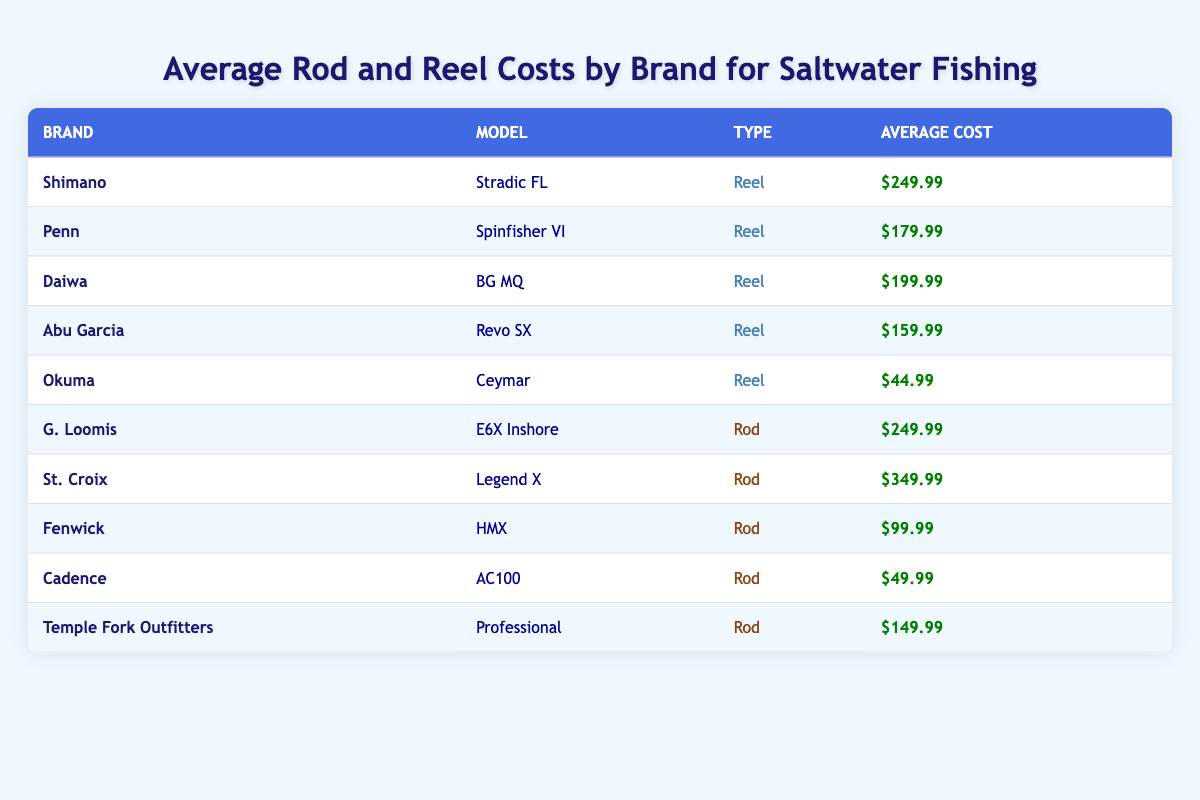What is the average cost of a rod from the table? To find the average cost of rods, we need to sum the average costs of the rods listed: \( 249.99 + 349.99 + 99.99 + 49.99 + 149.99 \). This totals to \( 899.95 \). Then, we divide by the number of rods, which is 5: \( 899.95 / 5 = 179.99 \).
Answer: 179.99 Which brand offers the cheapest reel? Looking through the table, the cheapest reel listed is the Okuma Ceymar with an average cost of $44.99.
Answer: Okuma True or False: The most expensive rod is by Daiwa. The table indicates that the St. Croix Legend X has the highest average cost of $349.99, while the highest cost for a Daiwa rod is not listed as it's primarily a reel in this case. Therefore, the statement is false.
Answer: False What is the difference in average cost between the most expensive rod and the most expensive reel? The most expensive rod, St. Croix Legend X, costs $349.99 and the most expensive reel, Shimano Stradic FL, costs $249.99. The difference is calculated as: \( 349.99 - 249.99 = 100 \).
Answer: 100 How many brands have a rod that costs less than $100? From the table, the brands with rods costing less than $100 are Fenwick (HMX at $99.99) and Cadence (AC100 at $49.99). Therefore, there are 2 brands meeting this criterion.
Answer: 2 What is the total cost of all the reels listed? The cost of all the reels is: \( 249.99 + 179.99 + 199.99 + 159.99 + 44.99 = 834.95 \). Thus, the total cost of all reels is $834.95.
Answer: 834.95 Is the average cost of a reel more than the average cost of a rod? The average cost of the reels is $166.99, and the average cost of the rods is $179.99. Since $166.99 is less than $179.99, the statement is false.
Answer: False Which brand has both a rod and a reel listed in the table? Reviewing the table, the brands Shimano, Penn, and Daiwa have reels listed, while G. Loomis, St. Croix, Fenwick, Cadence, and Temple Fork Outfitters have rods listed. The only brand with both is Shimano (Stradic FL reel and none listed for rod).
Answer: Shimano How much more expensive is the St. Croix Legend X compared to the Cadence AC100? The St. Croix Legend X costs $349.99 and the Cadence AC100 costs $49.99. The difference is: \( 349.99 - 49.99 = 300 \). So, it is $300 more expensive.
Answer: 300 